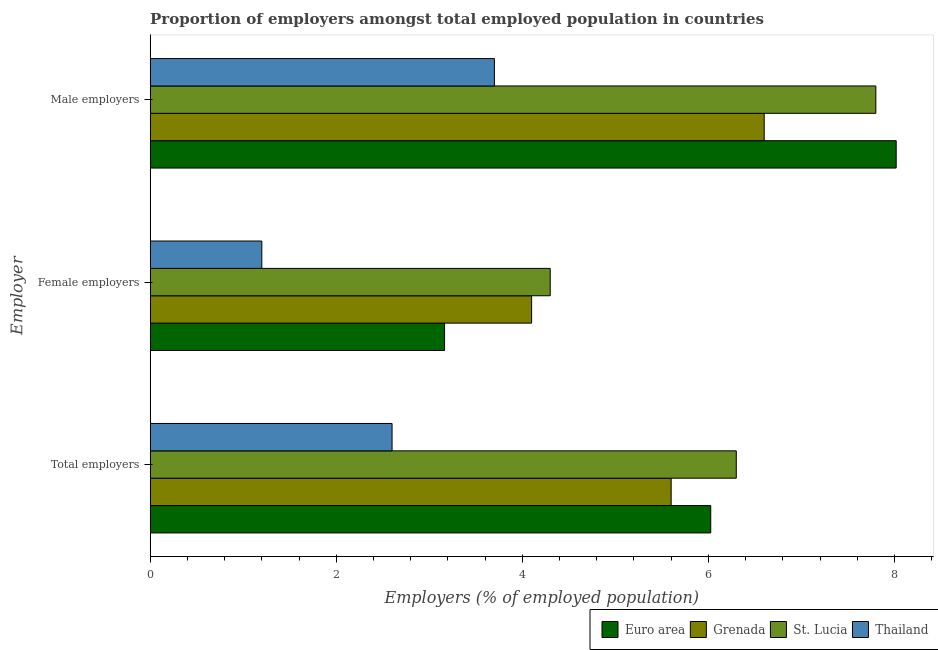How many different coloured bars are there?
Offer a terse response. 4. Are the number of bars per tick equal to the number of legend labels?
Keep it short and to the point. Yes. How many bars are there on the 2nd tick from the bottom?
Provide a short and direct response. 4. What is the label of the 2nd group of bars from the top?
Give a very brief answer. Female employers. What is the percentage of female employers in Thailand?
Your response must be concise. 1.2. Across all countries, what is the maximum percentage of male employers?
Make the answer very short. 8.02. Across all countries, what is the minimum percentage of total employers?
Offer a terse response. 2.6. In which country was the percentage of female employers maximum?
Ensure brevity in your answer.  St. Lucia. In which country was the percentage of male employers minimum?
Your response must be concise. Thailand. What is the total percentage of male employers in the graph?
Your answer should be compact. 26.12. What is the difference between the percentage of male employers in Thailand and that in Grenada?
Provide a succinct answer. -2.9. What is the difference between the percentage of male employers in Thailand and the percentage of total employers in Grenada?
Keep it short and to the point. -1.9. What is the average percentage of female employers per country?
Your answer should be compact. 3.19. What is the difference between the percentage of total employers and percentage of female employers in Euro area?
Offer a terse response. 2.86. What is the ratio of the percentage of female employers in Grenada to that in St. Lucia?
Ensure brevity in your answer.  0.95. Is the difference between the percentage of total employers in Thailand and Euro area greater than the difference between the percentage of male employers in Thailand and Euro area?
Provide a short and direct response. Yes. What is the difference between the highest and the second highest percentage of male employers?
Make the answer very short. 0.22. What is the difference between the highest and the lowest percentage of female employers?
Make the answer very short. 3.1. Is the sum of the percentage of male employers in Grenada and Thailand greater than the maximum percentage of total employers across all countries?
Make the answer very short. Yes. What does the 2nd bar from the top in Female employers represents?
Your answer should be very brief. St. Lucia. What does the 4th bar from the bottom in Female employers represents?
Your response must be concise. Thailand. How many bars are there?
Provide a succinct answer. 12. How many countries are there in the graph?
Make the answer very short. 4. What is the difference between two consecutive major ticks on the X-axis?
Your response must be concise. 2. What is the title of the graph?
Give a very brief answer. Proportion of employers amongst total employed population in countries. What is the label or title of the X-axis?
Your response must be concise. Employers (% of employed population). What is the label or title of the Y-axis?
Give a very brief answer. Employer. What is the Employers (% of employed population) of Euro area in Total employers?
Your response must be concise. 6.03. What is the Employers (% of employed population) of Grenada in Total employers?
Keep it short and to the point. 5.6. What is the Employers (% of employed population) of St. Lucia in Total employers?
Keep it short and to the point. 6.3. What is the Employers (% of employed population) in Thailand in Total employers?
Make the answer very short. 2.6. What is the Employers (% of employed population) of Euro area in Female employers?
Provide a succinct answer. 3.16. What is the Employers (% of employed population) in Grenada in Female employers?
Make the answer very short. 4.1. What is the Employers (% of employed population) of St. Lucia in Female employers?
Offer a very short reply. 4.3. What is the Employers (% of employed population) of Thailand in Female employers?
Your response must be concise. 1.2. What is the Employers (% of employed population) of Euro area in Male employers?
Provide a short and direct response. 8.02. What is the Employers (% of employed population) in Grenada in Male employers?
Offer a very short reply. 6.6. What is the Employers (% of employed population) of St. Lucia in Male employers?
Offer a terse response. 7.8. What is the Employers (% of employed population) of Thailand in Male employers?
Your response must be concise. 3.7. Across all Employer, what is the maximum Employers (% of employed population) of Euro area?
Provide a succinct answer. 8.02. Across all Employer, what is the maximum Employers (% of employed population) in Grenada?
Your response must be concise. 6.6. Across all Employer, what is the maximum Employers (% of employed population) in St. Lucia?
Give a very brief answer. 7.8. Across all Employer, what is the maximum Employers (% of employed population) of Thailand?
Offer a terse response. 3.7. Across all Employer, what is the minimum Employers (% of employed population) in Euro area?
Ensure brevity in your answer.  3.16. Across all Employer, what is the minimum Employers (% of employed population) of Grenada?
Ensure brevity in your answer.  4.1. Across all Employer, what is the minimum Employers (% of employed population) of St. Lucia?
Your answer should be compact. 4.3. Across all Employer, what is the minimum Employers (% of employed population) of Thailand?
Provide a succinct answer. 1.2. What is the total Employers (% of employed population) of Euro area in the graph?
Ensure brevity in your answer.  17.21. What is the difference between the Employers (% of employed population) of Euro area in Total employers and that in Female employers?
Your response must be concise. 2.86. What is the difference between the Employers (% of employed population) of Grenada in Total employers and that in Female employers?
Offer a terse response. 1.5. What is the difference between the Employers (% of employed population) of Euro area in Total employers and that in Male employers?
Offer a very short reply. -1.99. What is the difference between the Employers (% of employed population) in Grenada in Total employers and that in Male employers?
Your answer should be very brief. -1. What is the difference between the Employers (% of employed population) of Euro area in Female employers and that in Male employers?
Keep it short and to the point. -4.85. What is the difference between the Employers (% of employed population) in Euro area in Total employers and the Employers (% of employed population) in Grenada in Female employers?
Provide a succinct answer. 1.93. What is the difference between the Employers (% of employed population) in Euro area in Total employers and the Employers (% of employed population) in St. Lucia in Female employers?
Give a very brief answer. 1.73. What is the difference between the Employers (% of employed population) of Euro area in Total employers and the Employers (% of employed population) of Thailand in Female employers?
Offer a terse response. 4.83. What is the difference between the Employers (% of employed population) of St. Lucia in Total employers and the Employers (% of employed population) of Thailand in Female employers?
Keep it short and to the point. 5.1. What is the difference between the Employers (% of employed population) of Euro area in Total employers and the Employers (% of employed population) of Grenada in Male employers?
Keep it short and to the point. -0.57. What is the difference between the Employers (% of employed population) in Euro area in Total employers and the Employers (% of employed population) in St. Lucia in Male employers?
Offer a very short reply. -1.77. What is the difference between the Employers (% of employed population) in Euro area in Total employers and the Employers (% of employed population) in Thailand in Male employers?
Your answer should be very brief. 2.33. What is the difference between the Employers (% of employed population) of Grenada in Total employers and the Employers (% of employed population) of St. Lucia in Male employers?
Give a very brief answer. -2.2. What is the difference between the Employers (% of employed population) in Grenada in Total employers and the Employers (% of employed population) in Thailand in Male employers?
Provide a succinct answer. 1.9. What is the difference between the Employers (% of employed population) in St. Lucia in Total employers and the Employers (% of employed population) in Thailand in Male employers?
Ensure brevity in your answer.  2.6. What is the difference between the Employers (% of employed population) of Euro area in Female employers and the Employers (% of employed population) of Grenada in Male employers?
Your answer should be compact. -3.44. What is the difference between the Employers (% of employed population) of Euro area in Female employers and the Employers (% of employed population) of St. Lucia in Male employers?
Provide a short and direct response. -4.64. What is the difference between the Employers (% of employed population) in Euro area in Female employers and the Employers (% of employed population) in Thailand in Male employers?
Offer a terse response. -0.54. What is the difference between the Employers (% of employed population) in Grenada in Female employers and the Employers (% of employed population) in St. Lucia in Male employers?
Give a very brief answer. -3.7. What is the difference between the Employers (% of employed population) in Grenada in Female employers and the Employers (% of employed population) in Thailand in Male employers?
Offer a very short reply. 0.4. What is the average Employers (% of employed population) in Euro area per Employer?
Give a very brief answer. 5.74. What is the average Employers (% of employed population) in Grenada per Employer?
Make the answer very short. 5.43. What is the average Employers (% of employed population) of St. Lucia per Employer?
Give a very brief answer. 6.13. What is the difference between the Employers (% of employed population) of Euro area and Employers (% of employed population) of Grenada in Total employers?
Your response must be concise. 0.43. What is the difference between the Employers (% of employed population) in Euro area and Employers (% of employed population) in St. Lucia in Total employers?
Offer a terse response. -0.27. What is the difference between the Employers (% of employed population) in Euro area and Employers (% of employed population) in Thailand in Total employers?
Provide a succinct answer. 3.43. What is the difference between the Employers (% of employed population) of Grenada and Employers (% of employed population) of St. Lucia in Total employers?
Keep it short and to the point. -0.7. What is the difference between the Employers (% of employed population) of Grenada and Employers (% of employed population) of Thailand in Total employers?
Give a very brief answer. 3. What is the difference between the Employers (% of employed population) in Euro area and Employers (% of employed population) in Grenada in Female employers?
Make the answer very short. -0.94. What is the difference between the Employers (% of employed population) of Euro area and Employers (% of employed population) of St. Lucia in Female employers?
Your answer should be very brief. -1.14. What is the difference between the Employers (% of employed population) in Euro area and Employers (% of employed population) in Thailand in Female employers?
Make the answer very short. 1.96. What is the difference between the Employers (% of employed population) in Grenada and Employers (% of employed population) in St. Lucia in Female employers?
Offer a terse response. -0.2. What is the difference between the Employers (% of employed population) of Grenada and Employers (% of employed population) of Thailand in Female employers?
Ensure brevity in your answer.  2.9. What is the difference between the Employers (% of employed population) in St. Lucia and Employers (% of employed population) in Thailand in Female employers?
Offer a terse response. 3.1. What is the difference between the Employers (% of employed population) in Euro area and Employers (% of employed population) in Grenada in Male employers?
Keep it short and to the point. 1.42. What is the difference between the Employers (% of employed population) in Euro area and Employers (% of employed population) in St. Lucia in Male employers?
Provide a short and direct response. 0.22. What is the difference between the Employers (% of employed population) of Euro area and Employers (% of employed population) of Thailand in Male employers?
Give a very brief answer. 4.32. What is the difference between the Employers (% of employed population) in Grenada and Employers (% of employed population) in Thailand in Male employers?
Your answer should be compact. 2.9. What is the ratio of the Employers (% of employed population) of Euro area in Total employers to that in Female employers?
Keep it short and to the point. 1.9. What is the ratio of the Employers (% of employed population) of Grenada in Total employers to that in Female employers?
Your answer should be compact. 1.37. What is the ratio of the Employers (% of employed population) of St. Lucia in Total employers to that in Female employers?
Ensure brevity in your answer.  1.47. What is the ratio of the Employers (% of employed population) in Thailand in Total employers to that in Female employers?
Give a very brief answer. 2.17. What is the ratio of the Employers (% of employed population) in Euro area in Total employers to that in Male employers?
Offer a very short reply. 0.75. What is the ratio of the Employers (% of employed population) in Grenada in Total employers to that in Male employers?
Offer a terse response. 0.85. What is the ratio of the Employers (% of employed population) in St. Lucia in Total employers to that in Male employers?
Make the answer very short. 0.81. What is the ratio of the Employers (% of employed population) in Thailand in Total employers to that in Male employers?
Your answer should be compact. 0.7. What is the ratio of the Employers (% of employed population) of Euro area in Female employers to that in Male employers?
Make the answer very short. 0.39. What is the ratio of the Employers (% of employed population) in Grenada in Female employers to that in Male employers?
Ensure brevity in your answer.  0.62. What is the ratio of the Employers (% of employed population) of St. Lucia in Female employers to that in Male employers?
Offer a very short reply. 0.55. What is the ratio of the Employers (% of employed population) of Thailand in Female employers to that in Male employers?
Give a very brief answer. 0.32. What is the difference between the highest and the second highest Employers (% of employed population) of Euro area?
Offer a very short reply. 1.99. What is the difference between the highest and the lowest Employers (% of employed population) of Euro area?
Ensure brevity in your answer.  4.85. What is the difference between the highest and the lowest Employers (% of employed population) of St. Lucia?
Your answer should be very brief. 3.5. What is the difference between the highest and the lowest Employers (% of employed population) in Thailand?
Offer a very short reply. 2.5. 